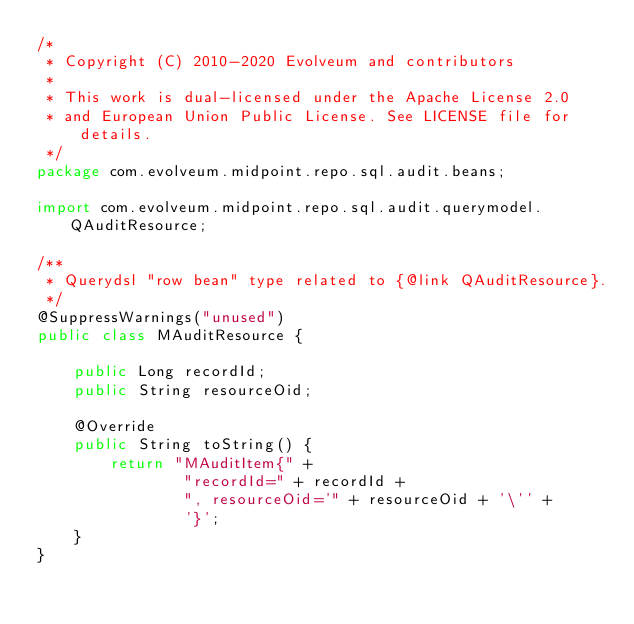Convert code to text. <code><loc_0><loc_0><loc_500><loc_500><_Java_>/*
 * Copyright (C) 2010-2020 Evolveum and contributors
 *
 * This work is dual-licensed under the Apache License 2.0
 * and European Union Public License. See LICENSE file for details.
 */
package com.evolveum.midpoint.repo.sql.audit.beans;

import com.evolveum.midpoint.repo.sql.audit.querymodel.QAuditResource;

/**
 * Querydsl "row bean" type related to {@link QAuditResource}.
 */
@SuppressWarnings("unused")
public class MAuditResource {

    public Long recordId;
    public String resourceOid;

    @Override
    public String toString() {
        return "MAuditItem{" +
                "recordId=" + recordId +
                ", resourceOid='" + resourceOid + '\'' +
                '}';
    }
}
</code> 